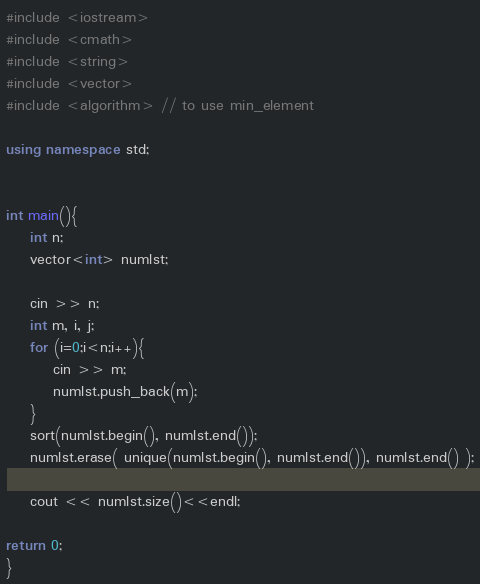Convert code to text. <code><loc_0><loc_0><loc_500><loc_500><_C++_>#include <iostream>
#include <cmath>
#include <string>
#include <vector>
#include <algorithm> // to use min_element

using namespace std;


int main(){
	int n;
	vector<int> numlst;

	cin >> n;
	int m, i, j;
	for (i=0;i<n;i++){
		cin >> m;
		numlst.push_back(m);	
	} 
	sort(numlst.begin(), numlst.end());
    numlst.erase( unique(numlst.begin(), numlst.end()), numlst.end() );

	cout << numlst.size()<<endl;

return 0;
}</code> 